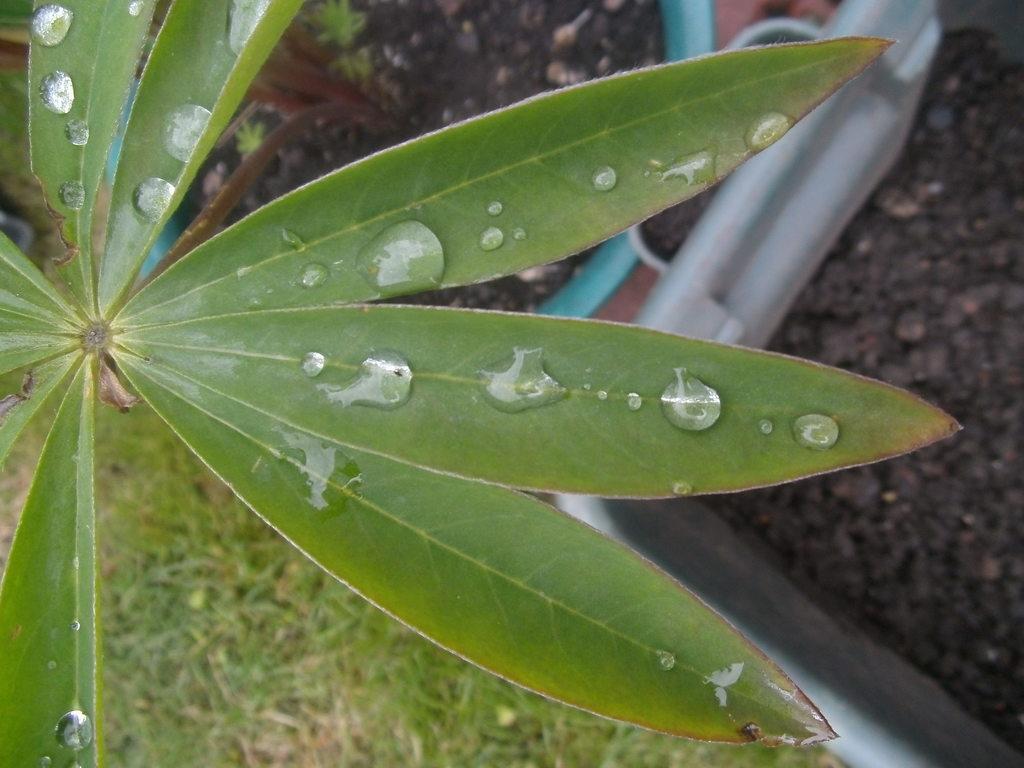How would you summarize this image in a sentence or two? In the center of the image we can see leaves. In the background there is a grass and ground. 